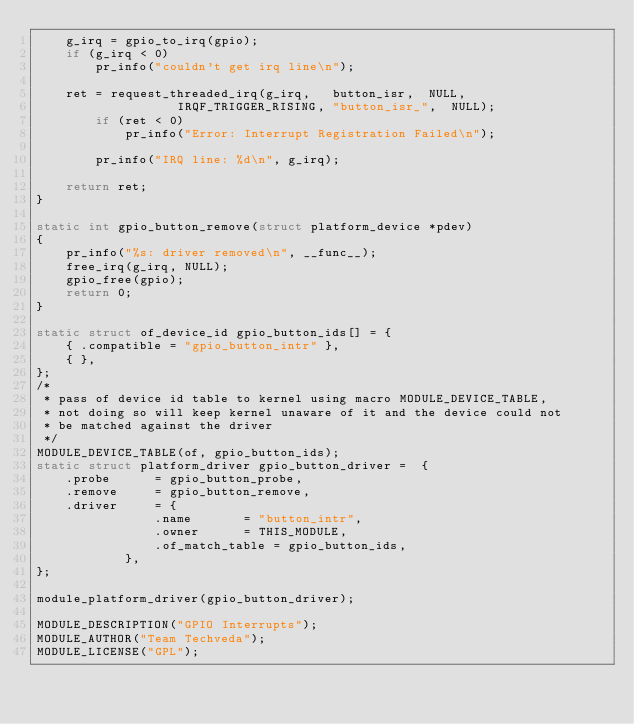<code> <loc_0><loc_0><loc_500><loc_500><_C_>	g_irq = gpio_to_irq(gpio);
	if (g_irq < 0)
		pr_info("couldn't get irq line\n");

	ret = request_threaded_irq(g_irq,   button_isr,  NULL, 
				   IRQF_TRIGGER_RISING, "button_isr_",  NULL);
		if (ret < 0) 
			pr_info("Error: Interrupt Registration Failed\n");

		pr_info("IRQ line: %d\n", g_irq);
	
	return ret;
}

static int gpio_button_remove(struct platform_device *pdev)
{
	pr_info("%s: driver removed\n", __func__);
	free_irq(g_irq, NULL);
	gpio_free(gpio);
	return 0;
}

static struct of_device_id gpio_button_ids[] = {
	{ .compatible = "gpio_button_intr" },
	{ },
};
/* 
 * pass of device id table to kernel using macro MODULE_DEVICE_TABLE, 
 * not doing so will keep kernel unaware of it and the device could not 
 * be matched against the driver
 */
MODULE_DEVICE_TABLE(of, gpio_button_ids);
static struct platform_driver gpio_button_driver =	{
	.probe		= gpio_button_probe,
	.remove		= gpio_button_remove,
	.driver		= {
				.name		= "button_intr",
				.owner 		= THIS_MODULE,
				.of_match_table	= gpio_button_ids,
			},
};

module_platform_driver(gpio_button_driver);

MODULE_DESCRIPTION("GPIO Interrupts");
MODULE_AUTHOR("Team Techveda");
MODULE_LICENSE("GPL");
</code> 